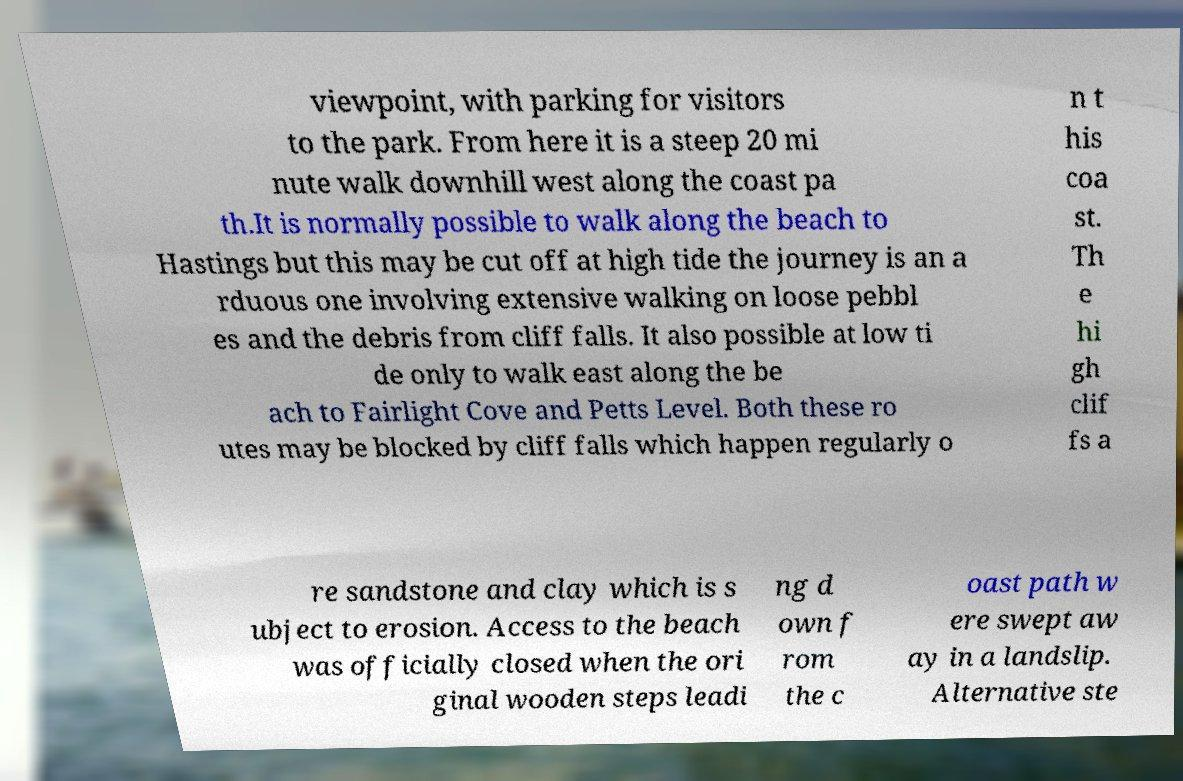I need the written content from this picture converted into text. Can you do that? viewpoint, with parking for visitors to the park. From here it is a steep 20 mi nute walk downhill west along the coast pa th.It is normally possible to walk along the beach to Hastings but this may be cut off at high tide the journey is an a rduous one involving extensive walking on loose pebbl es and the debris from cliff falls. It also possible at low ti de only to walk east along the be ach to Fairlight Cove and Petts Level. Both these ro utes may be blocked by cliff falls which happen regularly o n t his coa st. Th e hi gh clif fs a re sandstone and clay which is s ubject to erosion. Access to the beach was officially closed when the ori ginal wooden steps leadi ng d own f rom the c oast path w ere swept aw ay in a landslip. Alternative ste 